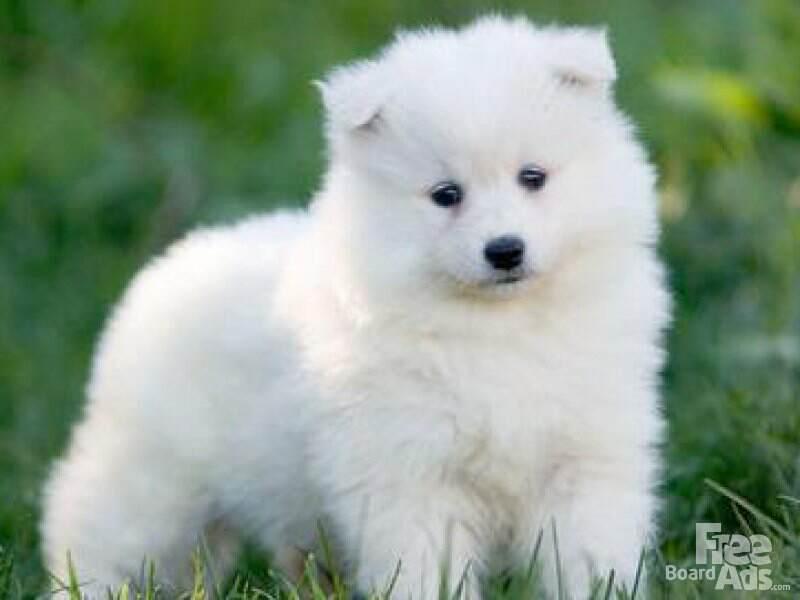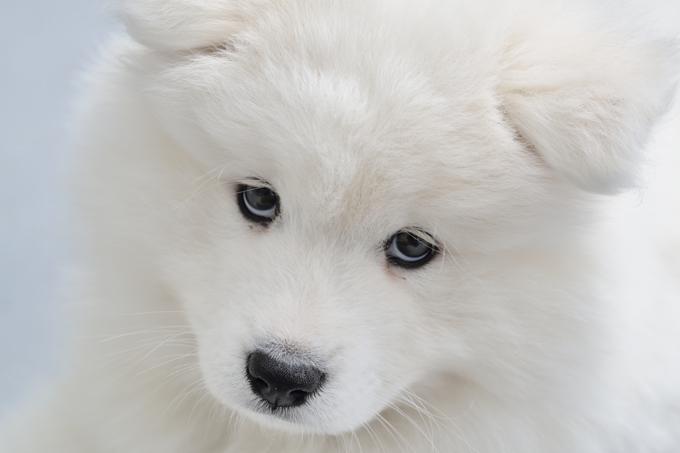The first image is the image on the left, the second image is the image on the right. Assess this claim about the two images: "There are a total of 5 white dogs.". Correct or not? Answer yes or no. No. 